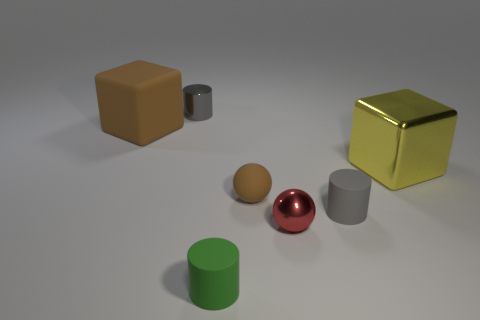Subtract all metallic cylinders. How many cylinders are left? 2 Subtract all blue cubes. How many gray cylinders are left? 2 Add 1 gray rubber things. How many objects exist? 8 Subtract 1 cylinders. How many cylinders are left? 2 Subtract all cubes. How many objects are left? 5 Subtract all purple cylinders. Subtract all brown blocks. How many cylinders are left? 3 Add 1 big metal cylinders. How many big metal cylinders exist? 1 Subtract 0 blue cylinders. How many objects are left? 7 Subtract all cyan cubes. Subtract all small gray metal things. How many objects are left? 6 Add 1 big yellow metallic blocks. How many big yellow metallic blocks are left? 2 